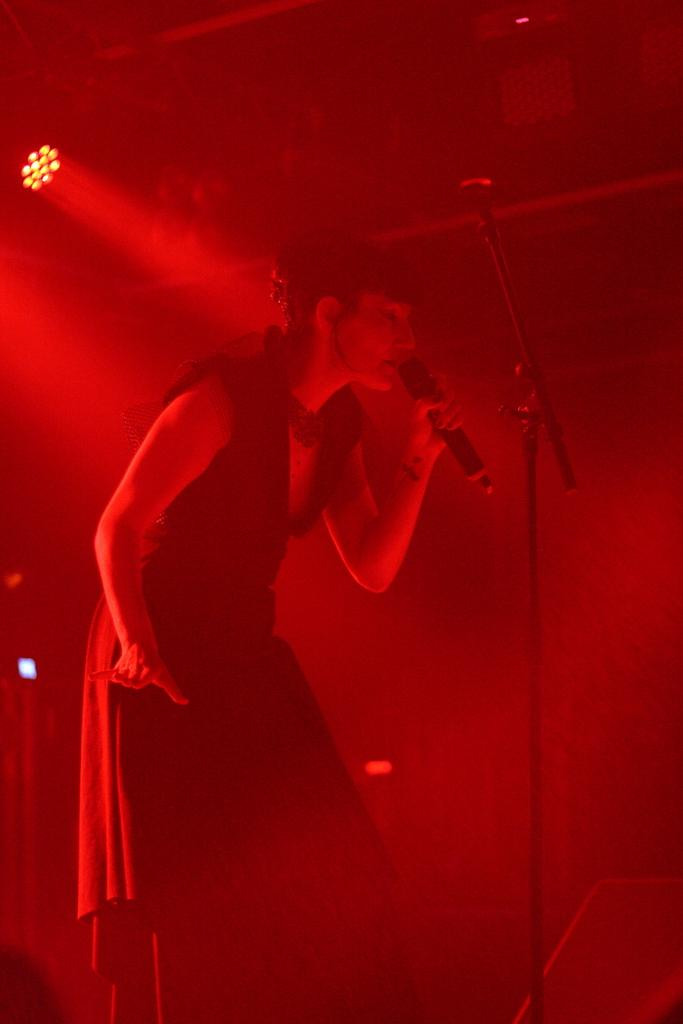What is the main subject of the image? There is a person in the image. What is the person doing in the image? The person is standing and holding a mic. What is in front of the person? There is a stand in front of the person. What can be seen on the wall behind the person? There is a light on the wall behind the person. What type of agreement is being discussed by the person in the image? There is no indication in the image that the person is discussing any agreement. 